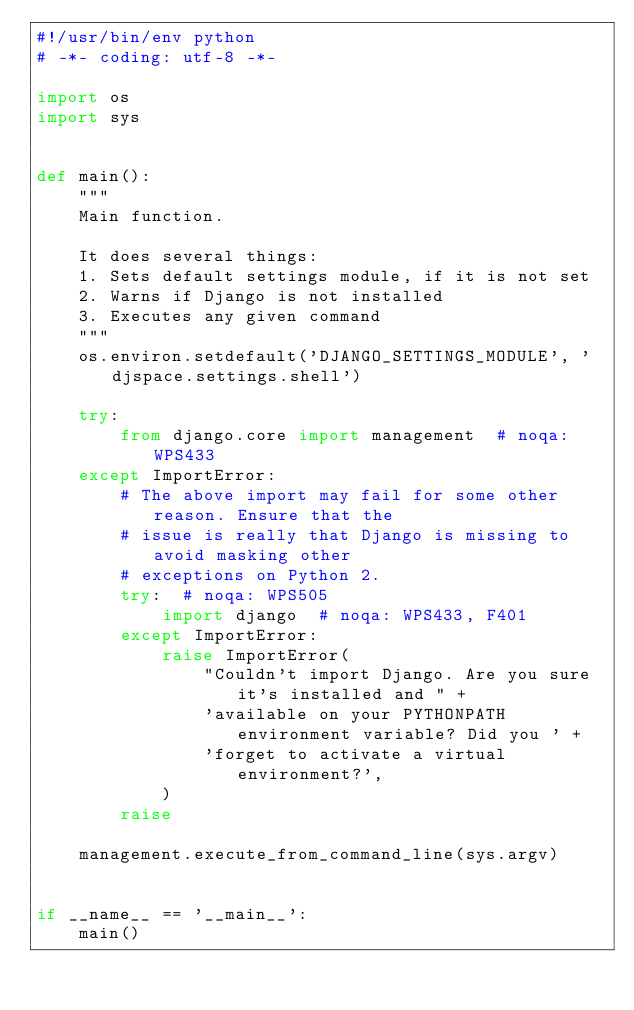<code> <loc_0><loc_0><loc_500><loc_500><_Python_>#!/usr/bin/env python
# -*- coding: utf-8 -*-

import os
import sys


def main():
    """
    Main function.

    It does several things:
    1. Sets default settings module, if it is not set
    2. Warns if Django is not installed
    3. Executes any given command
    """
    os.environ.setdefault('DJANGO_SETTINGS_MODULE', 'djspace.settings.shell')

    try:
        from django.core import management  # noqa: WPS433
    except ImportError:
        # The above import may fail for some other reason. Ensure that the
        # issue is really that Django is missing to avoid masking other
        # exceptions on Python 2.
        try:  # noqa: WPS505
            import django  # noqa: WPS433, F401
        except ImportError:
            raise ImportError(
                "Couldn't import Django. Are you sure it's installed and " +
                'available on your PYTHONPATH environment variable? Did you ' +
                'forget to activate a virtual environment?',
            )
        raise

    management.execute_from_command_line(sys.argv)


if __name__ == '__main__':
    main()
</code> 